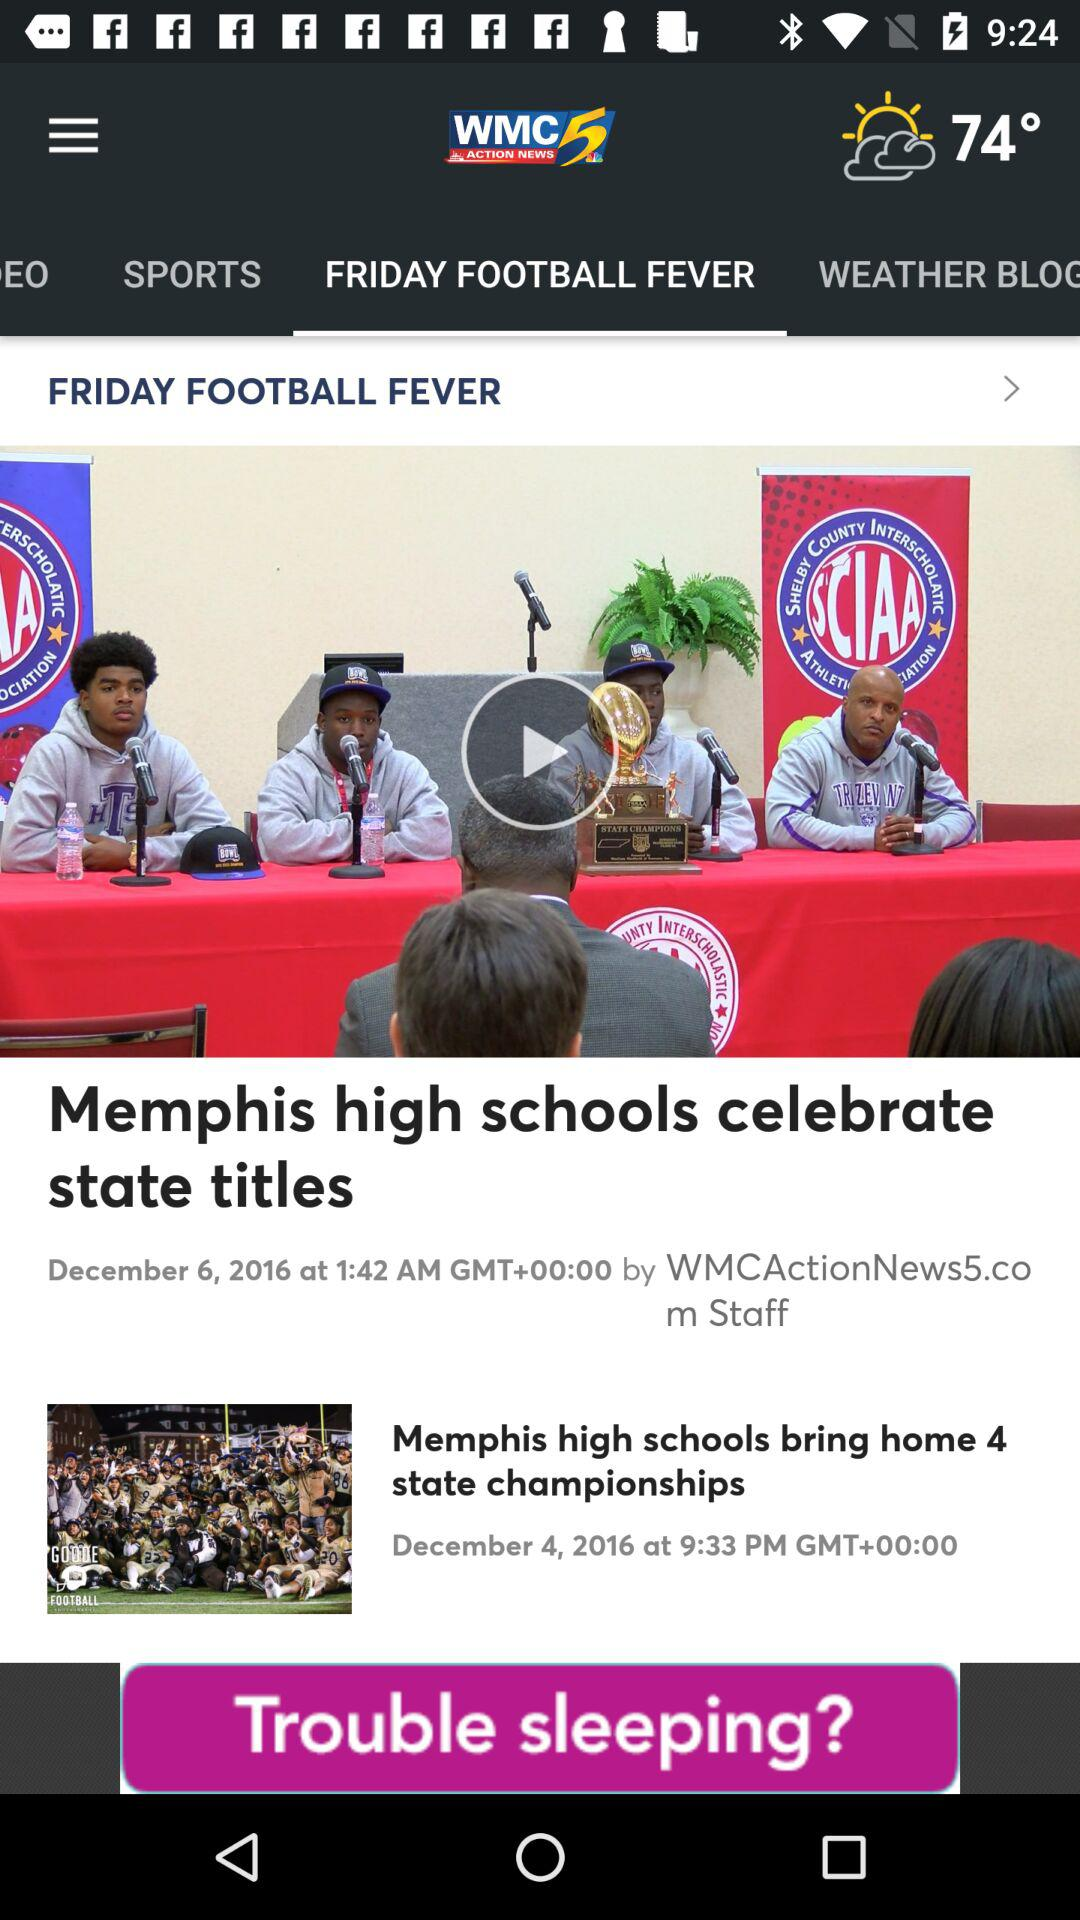Which is the selected tab? The selected tab is "FRIDAY FOOTBALL FEVER". 